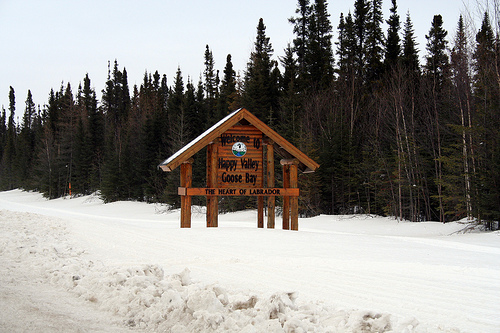<image>
Is the sign behind the trees? No. The sign is not behind the trees. From this viewpoint, the sign appears to be positioned elsewhere in the scene. 